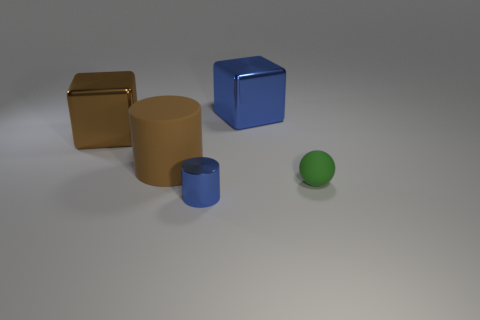The object that is the same color as the tiny metal cylinder is what shape?
Your answer should be very brief. Cube. What is the material of the brown cylinder that is in front of the object that is behind the object that is on the left side of the big matte cylinder?
Keep it short and to the point. Rubber. Is the shape of the matte thing that is left of the large blue shiny cube the same as  the tiny rubber object?
Provide a short and direct response. No. There is a block right of the large brown metallic block; what material is it?
Provide a succinct answer. Metal. How many matte things are large blue cubes or big brown blocks?
Your response must be concise. 0. Are there any things that have the same size as the green matte ball?
Offer a very short reply. Yes. Is the number of green objects on the left side of the big blue thing greater than the number of small spheres?
Ensure brevity in your answer.  No. How many large things are cubes or matte cylinders?
Your response must be concise. 3. What number of other objects have the same shape as the large brown matte object?
Provide a short and direct response. 1. What is the material of the large brown thing that is in front of the shiny thing left of the small shiny thing?
Ensure brevity in your answer.  Rubber. 